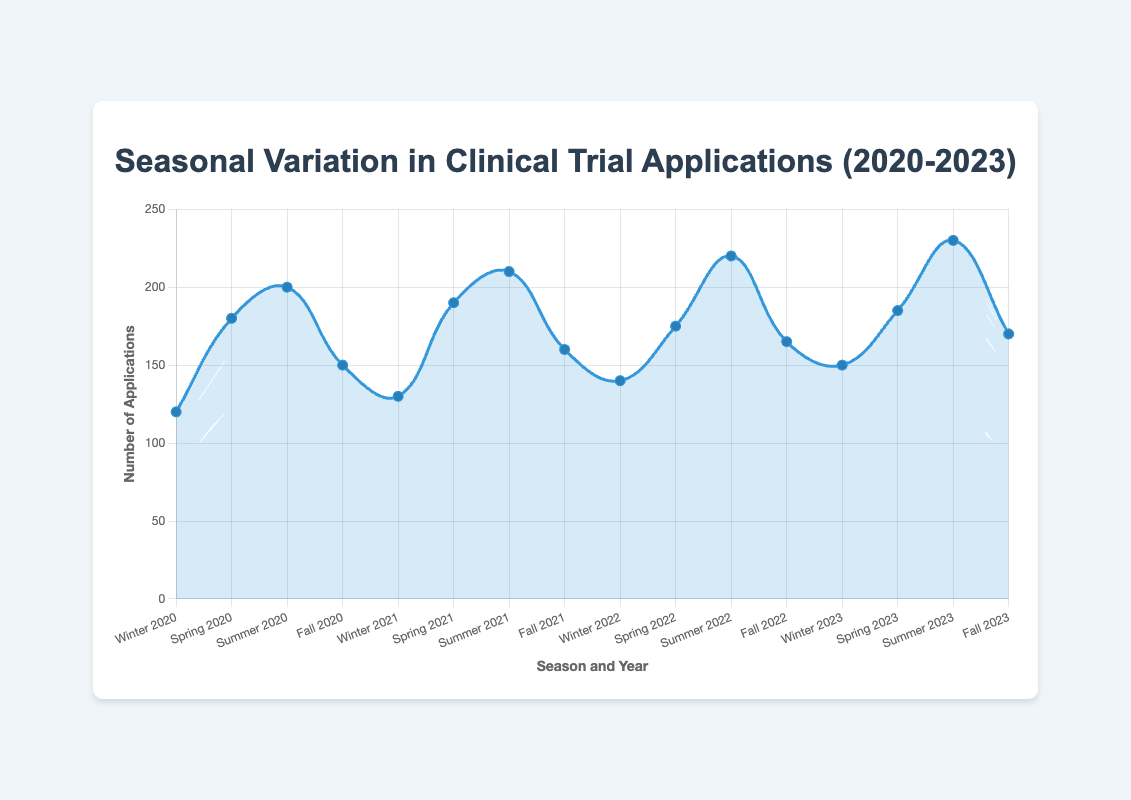What is the maximum number of clinical trial applications submitted in a single season? By inspecting the plot, we can find the peak point of the curve. The maximum number of applications is observed in Summer 2023 with 230 applications.
Answer: 230 In which season of 2021 were clinical trial applications the lowest? Referring to the year 2021 on the x-axis, the lowest point is Winter with 130 applications.
Answer: Winter What is the total number of clinical trial applications submitted in Spring across all years? Summing the data points for Spring: 180 (2020) + 190 (2021) + 175 (2022) + 185 (2023) = 730.
Answer: 730 How does the number of applications in Winter compare between 2020 and 2023? In Winter 2020, there were 120 applications, and in Winter 2023, there were 150 applications. 150 is greater than 120 by 30 applications.
Answer: 2023 > 2020 by 30 What is the average number of clinical trial applications submitted in Summer during the years 2020-2023? For Summers 2020, 2021, 2022, and 2023, the numbers are 200, 210, 220, and 230, respectively. The average is (200 + 210 + 220 + 230) / 4 = 215.
Answer: 215 Which year experienced the highest increase in clinical trial applications from Winter to Summer? Calculate differences: 
- 2020: 200 - 120 = 80 
- 2021: 210 - 130 = 80 
- 2022: 220 - 140 = 80 
- 2023: 230 - 150 = 80 
Each year experienced an increase of 80, so all years are equal.
Answer: All years were equal with an increase of 80 How did the number of applications in Fall change from 2020 to 2023? Applications in Fall 2020 were 150, and in Fall 2023 were 170. The increase is 20 applications.
Answer: Increased by 20 Which season consistently shows an upward trend in applications from 2020 to 2023? On examining each data point season-wise: 
- Winter: 120 -> 130 -> 140 -> 150 
- Spring: 180 -> 190 -> 175 -> 185 
- Summer: 200 -> 210 -> 220 -> 230 
- Fall: 150 -> 160 -> 165 -> 170 
Winter and Summer show consistent upward trends.
Answer: Winter and Summer What are the years where Summer had the highest number of applications as compared to other seasons? For each year:
- 2020: Summer 200 > Spring 180, Fall 150, Winter 120
- 2021: Summer 210 > Spring 190, Fall 160, Winter 130
- 2022: Summer 220 > Spring 175, Fall 165, Winter 140
- 2023: Summer 230 > Spring 185, Fall 170, Winter 150
In all years from 2020 to 2023, Summer had the highest.
Answer: 2020, 2021, 2022, 2023 